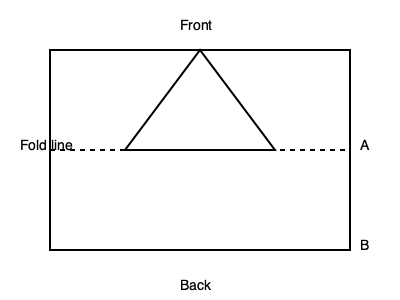The diagram shows a paper model of a traditional Sri Lankan dagoba (stupa) when unfolded. If you fold the paper along the dotted line, which part (A or B) will be visible from the front? To solve this problem, we need to visualize the folding process:

1. The dotted line represents the fold line, which divides the paper into two halves.

2. The upper half contains a triangle shape, which represents the conical part of the dagoba.

3. When folded, the paper will be bent along the dotted line, bringing the bottom half (B) up and behind the top half (A).

4. The triangular shape in the top half will form the visible front of the dagoba.

5. Part A, which is above the fold line, will remain visible after folding.

6. Part B, which is below the fold line, will be hidden behind part A when the paper is folded.

Therefore, when the paper is folded to create the 3D model of the dagoba, part A will be visible from the front.
Answer: A 